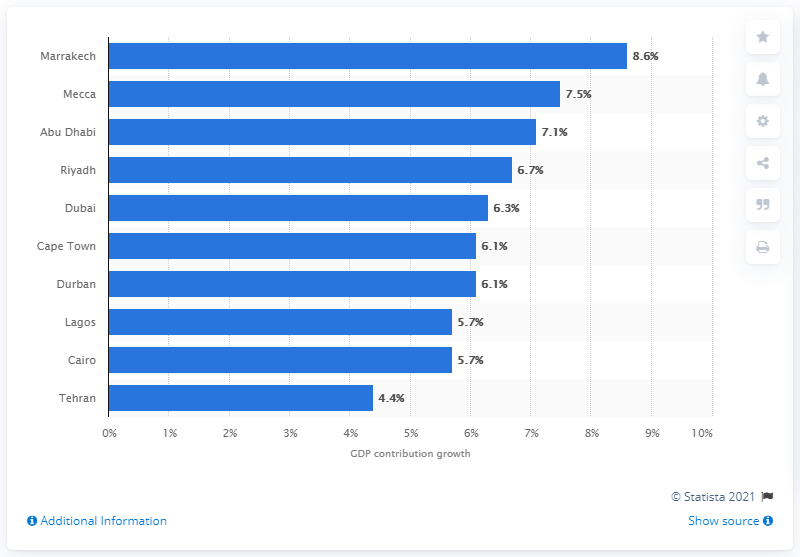Mention a couple of crucial points in this snapshot. According to projections, the growth of tourism's contribution to the GDP of Morocco is expected to be 8.6% by the year 2023. 